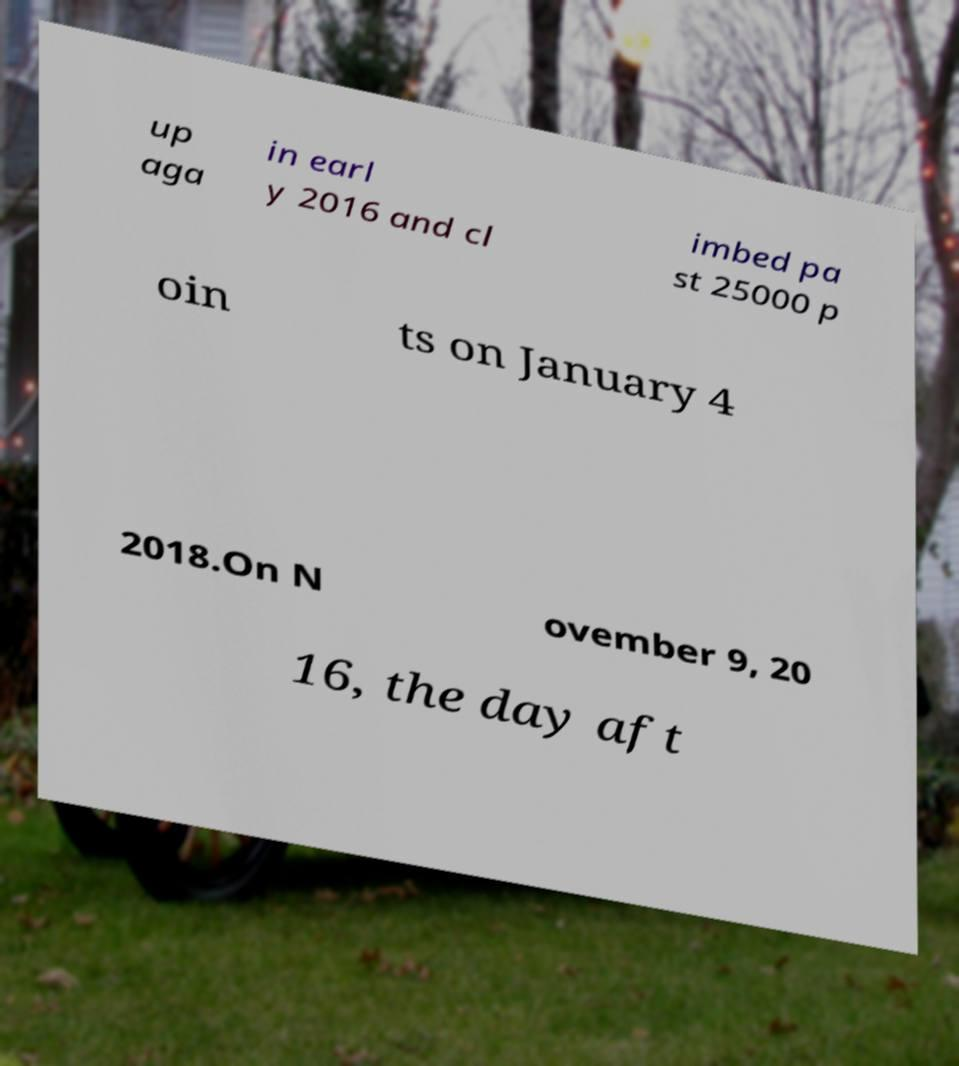Please identify and transcribe the text found in this image. up aga in earl y 2016 and cl imbed pa st 25000 p oin ts on January 4 2018.On N ovember 9, 20 16, the day aft 